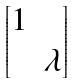Convert formula to latex. <formula><loc_0><loc_0><loc_500><loc_500>\begin{bmatrix} 1 & \\ & \lambda \end{bmatrix}</formula> 